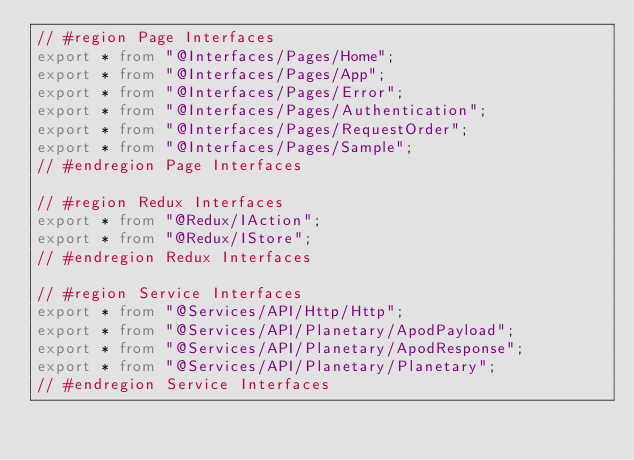<code> <loc_0><loc_0><loc_500><loc_500><_TypeScript_>// #region Page Interfaces
export * from "@Interfaces/Pages/Home";
export * from "@Interfaces/Pages/App";
export * from "@Interfaces/Pages/Error";
export * from "@Interfaces/Pages/Authentication";
export * from "@Interfaces/Pages/RequestOrder";
export * from "@Interfaces/Pages/Sample";
// #endregion Page Interfaces

// #region Redux Interfaces
export * from "@Redux/IAction";
export * from "@Redux/IStore";
// #endregion Redux Interfaces

// #region Service Interfaces
export * from "@Services/API/Http/Http";
export * from "@Services/API/Planetary/ApodPayload";
export * from "@Services/API/Planetary/ApodResponse";
export * from "@Services/API/Planetary/Planetary";
// #endregion Service Interfaces
</code> 